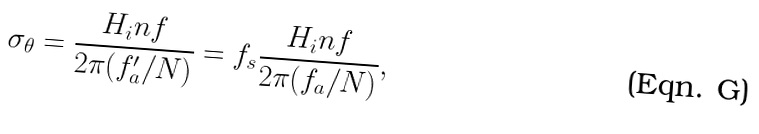Convert formula to latex. <formula><loc_0><loc_0><loc_500><loc_500>\sigma _ { \theta } = \frac { H _ { i } n f } { 2 \pi ( f ^ { \prime } _ { a } / N ) } = f _ { s } \frac { H _ { i } n f } { 2 \pi ( f _ { a } / N ) } ,</formula> 